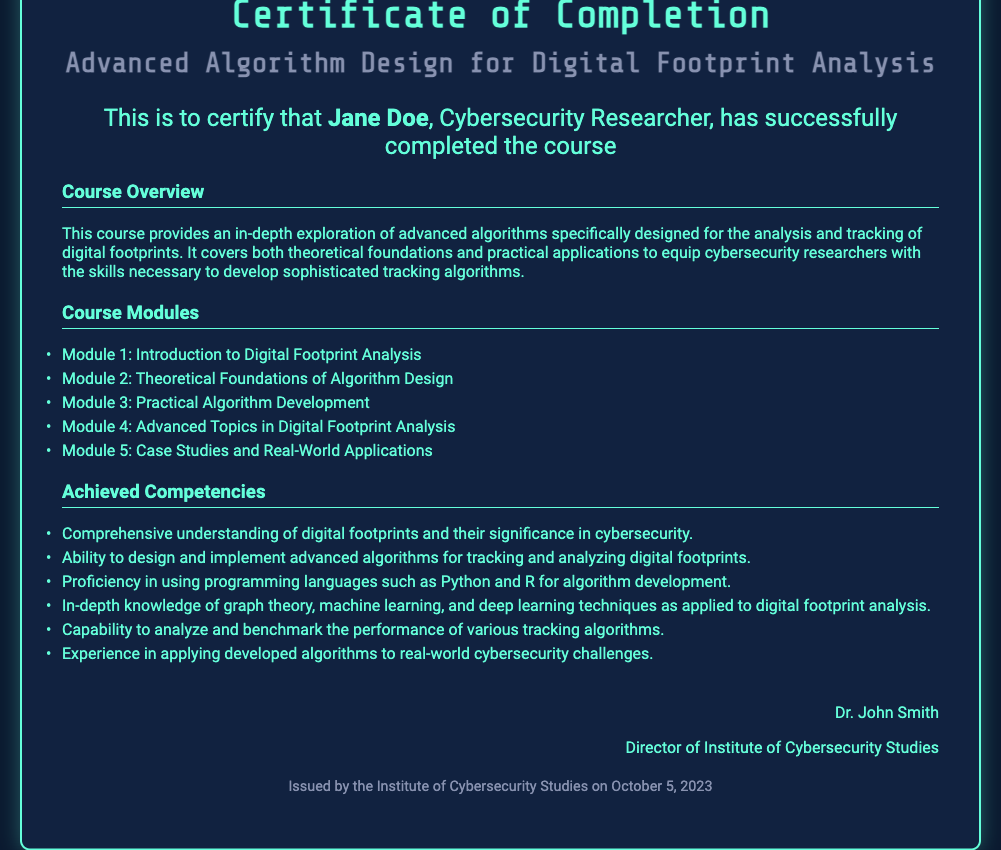What is the title of the course? The title of the course is mentioned in the heading of the document as "Advanced Algorithm Design for Digital Footprint Analysis."
Answer: Advanced Algorithm Design for Digital Footprint Analysis Who is the recipient of the certificate? The recipient's name is specified in the certificate text, stating "This is to certify that Jane Doe."
Answer: Jane Doe What is the date of issue for this certificate? The date of issue is found in the footer of the document, which states "Issued by the Institute of Cybersecurity Studies on October 5, 2023."
Answer: October 5, 2023 How many modules are listed in the course? The total number of modules can be counted from the list under "Course Modules," which includes five items.
Answer: 5 What competency is gained related to programming languages? One of the achieved competencies states "Proficiency in using programming languages such as Python and R for algorithm development."
Answer: Python and R Who is the signatory of the certificate? The document indicates the signatory at the bottom, naming "Dr. John Smith."
Answer: Dr. John Smith What type of analysis is the focus of the course? The document describes the focus of the course as "analysis and tracking of digital footprints."
Answer: Digital footprint analysis What institution issued the certificate? The issuing institution is mentioned at the footer of the document as "Institute of Cybersecurity Studies."
Answer: Institute of Cybersecurity Studies What is one advanced topic covered in the course? One of the listed modules is "Advanced Topics in Digital Footprint Analysis," indicating the area of study.
Answer: Advanced Topics in Digital Footprint Analysis 